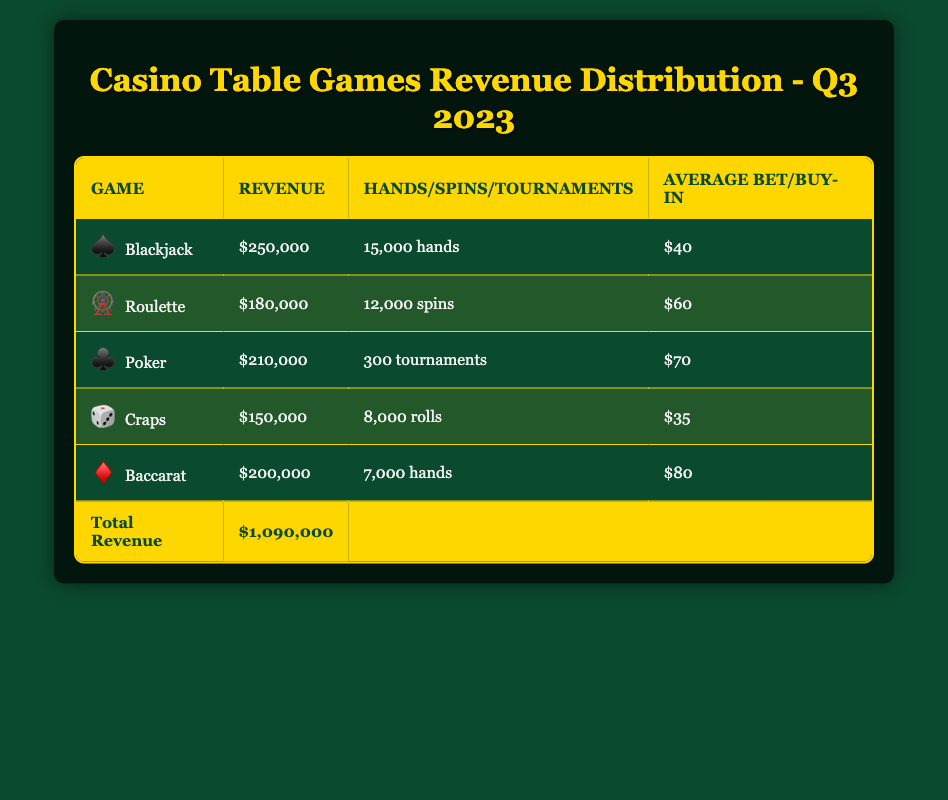What is the total revenue generated by all games combined in Q3 2023? The total revenue for Q3 2023 is provided in the table under the "Total Revenue" row. It states that the total revenue is $1,090,000.
Answer: 1,090,000 How much revenue did Blackjack generate? The table shows that Blackjack generated a revenue of $250,000 as stated in the "Revenue" column for the Blackjack row.
Answer: 250,000 Which game had the highest average bet? By looking at the "Average Bet" column, Baccarat has the highest average bet of $80, which is greater than the average bets of Blackjack ($40), Roulette ($60), Craps ($35), and Poker ($70).
Answer: Baccarat Is the revenue from Poker greater than that from Roulette? The table shows that Poker generated $210,000 in revenue while Roulette generated $180,000. Since $210,000 is greater than $180,000, the answer is yes.
Answer: Yes What is the difference in revenue between Blackjack and Craps? To find the revenue difference, subtract the revenue of Craps from Blackjack: $250,000 (Blackjack) - $150,000 (Craps) = $100,000. This calculation shows the revenue difference between the two games.
Answer: 100,000 What is the average revenue per tournament for Poker? Poker generated $210,000 in revenue over 300 tournaments. To find the average revenue per tournament, divide the total revenue by the number of tournaments: $210,000 / 300 = $700. This provides the average revenue for each tournament.
Answer: 700 Which game had the least revenue, and what was its amount? Looking at the "Revenue" column, Craps generated the least revenue, with a total of $150,000, which is lower than the revenue generated by all other games listed.
Answer: Craps, 150,000 What percentage of the total revenue is contributed by Baccarat? Baccarat generated $200,000. To find the percentage, divide Baccarat's revenue by the total revenue and multiply by 100: ($200,000 / $1,090,000) * 100 ≈ 18.35%. This shows how much of the total revenue came from Baccarat.
Answer: 18.35% What is the total number of hands played across Blackjack and Baccarat? Blackjack had 15,000 hands played, and Baccarat had 7,000 hands played. To find the total, we add them together: 15,000 + 7,000 = 22,000. This gives the combined total of hands played for these two games.
Answer: 22,000 